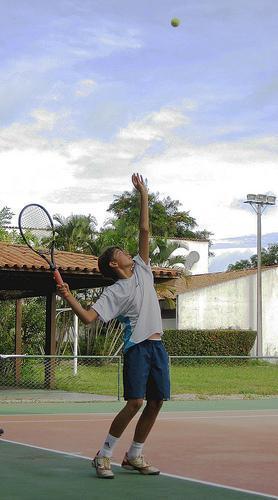How many players are there?
Give a very brief answer. 1. 